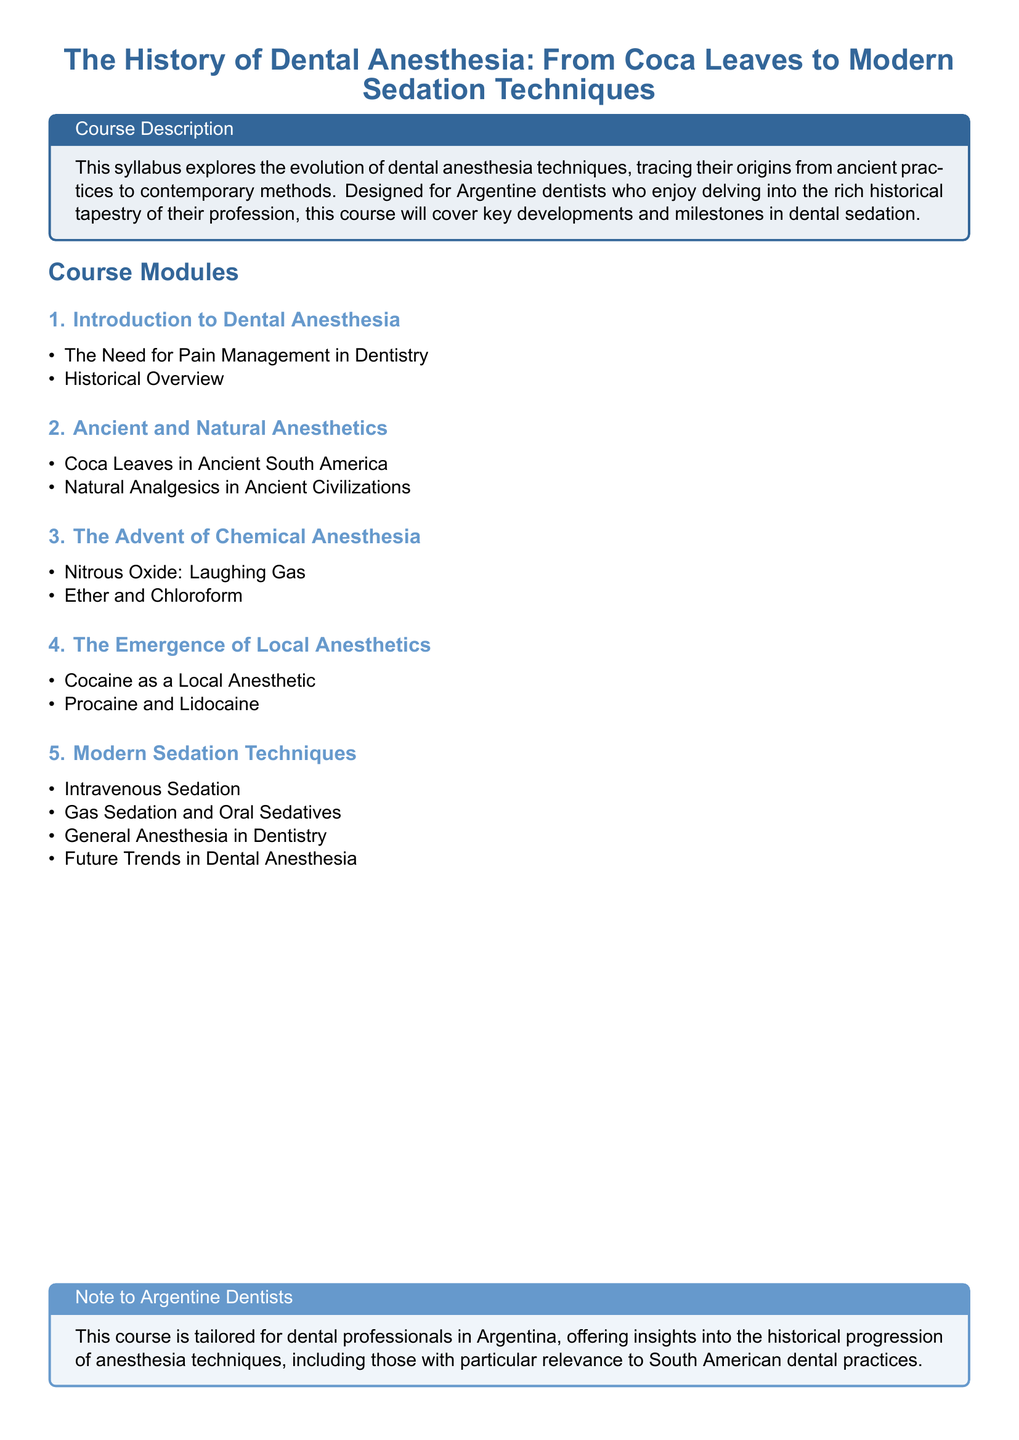What is the title of the course? The title of the course is prominently displayed and focuses on the history of dental anesthesia.
Answer: The History of Dental Anesthesia: From Coca Leaves to Modern Sedation Techniques Who is the intended audience for this course? The course is specifically tailored for a particular group of professionals.
Answer: Argentine dentists What is the first module of the course? The first module introduces key concepts related to dental anesthesia.
Answer: Introduction to Dental Anesthesia What anesthetic is highlighted in the section on Ancient and Natural Anesthetics? The document mentions this natural anesthetic from ancient South America.
Answer: Coca Leaves What type of anesthesia is associated with the term "Laughing Gas"? This term is a common nickname for a specific type of chemical anesthesia covered in the syllabus.
Answer: Nitrous Oxide Which local anesthetic was introduced after cocaine? This section discusses advancements in local anesthetics, following cocaine.
Answer: Procaine What is the focus of the last module in the course? The last module addresses modern practices and future developments in a specific field.
Answer: Modern Sedation Techniques How many main modules are listed in the syllabus? The document outlines the structure, leading to this count of main modules.
Answer: Five 